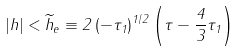Convert formula to latex. <formula><loc_0><loc_0><loc_500><loc_500>\left | h \right | < \widetilde { h } _ { e } \equiv 2 \left ( - \tau _ { 1 } \right ) ^ { 1 / 2 } \left ( \tau - \frac { 4 } { 3 } \tau _ { 1 } \right )</formula> 